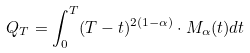<formula> <loc_0><loc_0><loc_500><loc_500>Q _ { T } = \int _ { 0 } ^ { T } ( T - t ) ^ { 2 ( 1 - \alpha ) } \cdot M _ { \alpha } ( t ) d t</formula> 